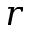<formula> <loc_0><loc_0><loc_500><loc_500>r</formula> 